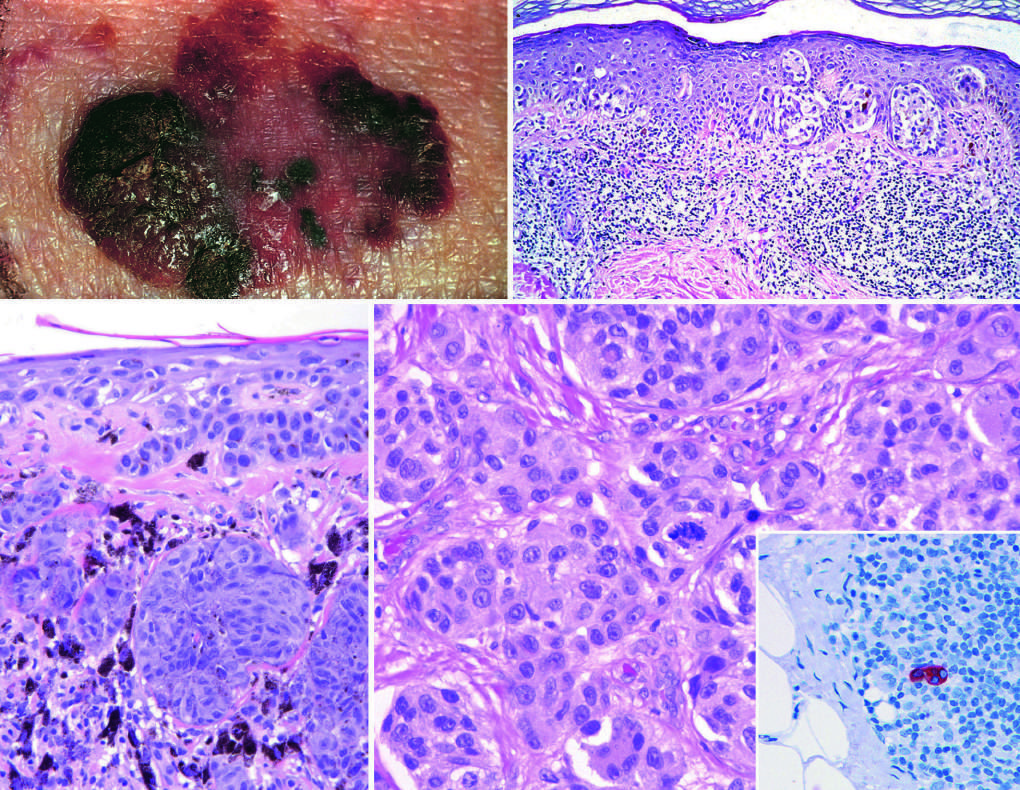what do macular areas indicate?
Answer the question using a single word or phrase. Superficial growth 